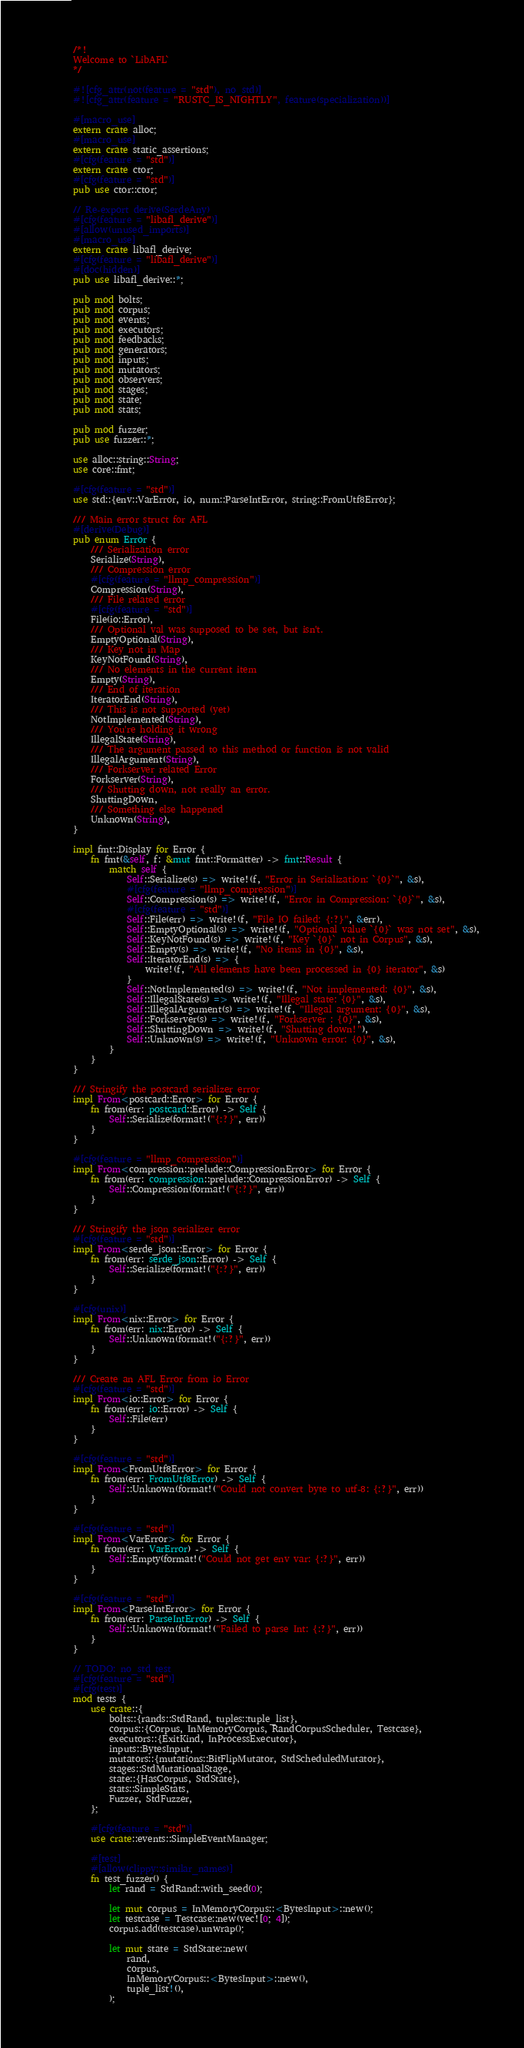<code> <loc_0><loc_0><loc_500><loc_500><_Rust_>/*!
Welcome to `LibAFL`
*/

#![cfg_attr(not(feature = "std"), no_std)]
#![cfg_attr(feature = "RUSTC_IS_NIGHTLY", feature(specialization))]

#[macro_use]
extern crate alloc;
#[macro_use]
extern crate static_assertions;
#[cfg(feature = "std")]
extern crate ctor;
#[cfg(feature = "std")]
pub use ctor::ctor;

// Re-export derive(SerdeAny)
#[cfg(feature = "libafl_derive")]
#[allow(unused_imports)]
#[macro_use]
extern crate libafl_derive;
#[cfg(feature = "libafl_derive")]
#[doc(hidden)]
pub use libafl_derive::*;

pub mod bolts;
pub mod corpus;
pub mod events;
pub mod executors;
pub mod feedbacks;
pub mod generators;
pub mod inputs;
pub mod mutators;
pub mod observers;
pub mod stages;
pub mod state;
pub mod stats;

pub mod fuzzer;
pub use fuzzer::*;

use alloc::string::String;
use core::fmt;

#[cfg(feature = "std")]
use std::{env::VarError, io, num::ParseIntError, string::FromUtf8Error};

/// Main error struct for AFL
#[derive(Debug)]
pub enum Error {
    /// Serialization error
    Serialize(String),
    /// Compression error
    #[cfg(feature = "llmp_compression")]
    Compression(String),
    /// File related error
    #[cfg(feature = "std")]
    File(io::Error),
    /// Optional val was supposed to be set, but isn't.
    EmptyOptional(String),
    /// Key not in Map
    KeyNotFound(String),
    /// No elements in the current item
    Empty(String),
    /// End of iteration
    IteratorEnd(String),
    /// This is not supported (yet)
    NotImplemented(String),
    /// You're holding it wrong
    IllegalState(String),
    /// The argument passed to this method or function is not valid
    IllegalArgument(String),
    /// Forkserver related Error
    Forkserver(String),
    /// Shutting down, not really an error.
    ShuttingDown,
    /// Something else happened
    Unknown(String),
}

impl fmt::Display for Error {
    fn fmt(&self, f: &mut fmt::Formatter) -> fmt::Result {
        match self {
            Self::Serialize(s) => write!(f, "Error in Serialization: `{0}`", &s),
            #[cfg(feature = "llmp_compression")]
            Self::Compression(s) => write!(f, "Error in Compression: `{0}`", &s),
            #[cfg(feature = "std")]
            Self::File(err) => write!(f, "File IO failed: {:?}", &err),
            Self::EmptyOptional(s) => write!(f, "Optional value `{0}` was not set", &s),
            Self::KeyNotFound(s) => write!(f, "Key `{0}` not in Corpus", &s),
            Self::Empty(s) => write!(f, "No items in {0}", &s),
            Self::IteratorEnd(s) => {
                write!(f, "All elements have been processed in {0} iterator", &s)
            }
            Self::NotImplemented(s) => write!(f, "Not implemented: {0}", &s),
            Self::IllegalState(s) => write!(f, "Illegal state: {0}", &s),
            Self::IllegalArgument(s) => write!(f, "Illegal argument: {0}", &s),
            Self::Forkserver(s) => write!(f, "Forkserver : {0}", &s),
            Self::ShuttingDown => write!(f, "Shutting down!"),
            Self::Unknown(s) => write!(f, "Unknown error: {0}", &s),
        }
    }
}

/// Stringify the postcard serializer error
impl From<postcard::Error> for Error {
    fn from(err: postcard::Error) -> Self {
        Self::Serialize(format!("{:?}", err))
    }
}

#[cfg(feature = "llmp_compression")]
impl From<compression::prelude::CompressionError> for Error {
    fn from(err: compression::prelude::CompressionError) -> Self {
        Self::Compression(format!("{:?}", err))
    }
}

/// Stringify the json serializer error
#[cfg(feature = "std")]
impl From<serde_json::Error> for Error {
    fn from(err: serde_json::Error) -> Self {
        Self::Serialize(format!("{:?}", err))
    }
}

#[cfg(unix)]
impl From<nix::Error> for Error {
    fn from(err: nix::Error) -> Self {
        Self::Unknown(format!("{:?}", err))
    }
}

/// Create an AFL Error from io Error
#[cfg(feature = "std")]
impl From<io::Error> for Error {
    fn from(err: io::Error) -> Self {
        Self::File(err)
    }
}

#[cfg(feature = "std")]
impl From<FromUtf8Error> for Error {
    fn from(err: FromUtf8Error) -> Self {
        Self::Unknown(format!("Could not convert byte to utf-8: {:?}", err))
    }
}

#[cfg(feature = "std")]
impl From<VarError> for Error {
    fn from(err: VarError) -> Self {
        Self::Empty(format!("Could not get env var: {:?}", err))
    }
}

#[cfg(feature = "std")]
impl From<ParseIntError> for Error {
    fn from(err: ParseIntError) -> Self {
        Self::Unknown(format!("Failed to parse Int: {:?}", err))
    }
}

// TODO: no_std test
#[cfg(feature = "std")]
#[cfg(test)]
mod tests {
    use crate::{
        bolts::{rands::StdRand, tuples::tuple_list},
        corpus::{Corpus, InMemoryCorpus, RandCorpusScheduler, Testcase},
        executors::{ExitKind, InProcessExecutor},
        inputs::BytesInput,
        mutators::{mutations::BitFlipMutator, StdScheduledMutator},
        stages::StdMutationalStage,
        state::{HasCorpus, StdState},
        stats::SimpleStats,
        Fuzzer, StdFuzzer,
    };

    #[cfg(feature = "std")]
    use crate::events::SimpleEventManager;

    #[test]
    #[allow(clippy::similar_names)]
    fn test_fuzzer() {
        let rand = StdRand::with_seed(0);

        let mut corpus = InMemoryCorpus::<BytesInput>::new();
        let testcase = Testcase::new(vec![0; 4]);
        corpus.add(testcase).unwrap();

        let mut state = StdState::new(
            rand,
            corpus,
            InMemoryCorpus::<BytesInput>::new(),
            tuple_list!(),
        );
</code> 